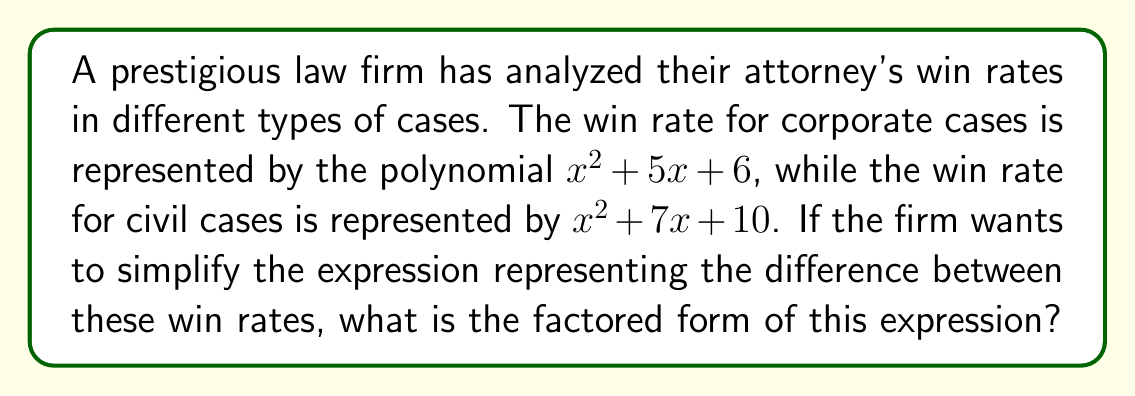Can you solve this math problem? To solve this problem, we'll follow these steps:

1) First, we need to find the difference between the two polynomials:
   $(x^2 + 7x + 10) - (x^2 + 5x + 6)$

2) Simplify by subtracting like terms:
   $x^2 + 7x + 10 - x^2 - 5x - 6$
   The $x^2$ terms cancel out, leaving us with:
   $2x + 4$

3) Now we need to factor this expression. Since it's a linear expression (degree 1), we can factor out the greatest common factor (GCF):

   The GCF of $2x$ and $4$ is $2$.

4) Factor out 2:
   $2x + 4 = 2(x + 2)$

Thus, the factored form of the difference between the win rates is $2(x + 2)$.

This simplified expression represents the difference in win rates between civil and corporate cases, factored to its simplest form. As an aspiring lawyer, understanding these numerical representations of case outcomes could provide valuable insights into a firm's performance in different areas of law.
Answer: $2(x + 2)$ 